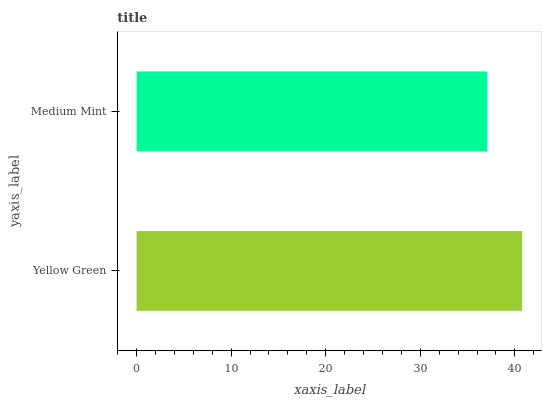Is Medium Mint the minimum?
Answer yes or no. Yes. Is Yellow Green the maximum?
Answer yes or no. Yes. Is Medium Mint the maximum?
Answer yes or no. No. Is Yellow Green greater than Medium Mint?
Answer yes or no. Yes. Is Medium Mint less than Yellow Green?
Answer yes or no. Yes. Is Medium Mint greater than Yellow Green?
Answer yes or no. No. Is Yellow Green less than Medium Mint?
Answer yes or no. No. Is Yellow Green the high median?
Answer yes or no. Yes. Is Medium Mint the low median?
Answer yes or no. Yes. Is Medium Mint the high median?
Answer yes or no. No. Is Yellow Green the low median?
Answer yes or no. No. 